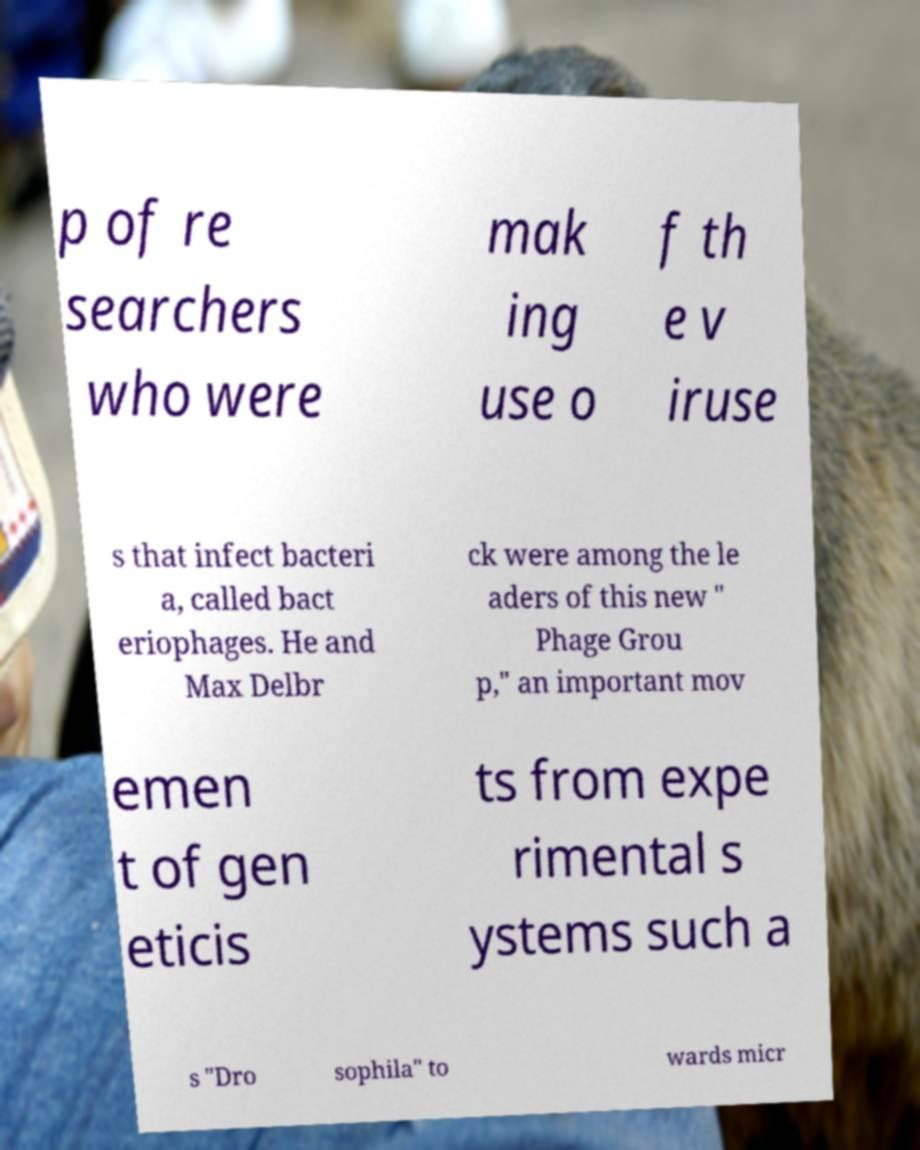Could you assist in decoding the text presented in this image and type it out clearly? p of re searchers who were mak ing use o f th e v iruse s that infect bacteri a, called bact eriophages. He and Max Delbr ck were among the le aders of this new " Phage Grou p," an important mov emen t of gen eticis ts from expe rimental s ystems such a s "Dro sophila" to wards micr 